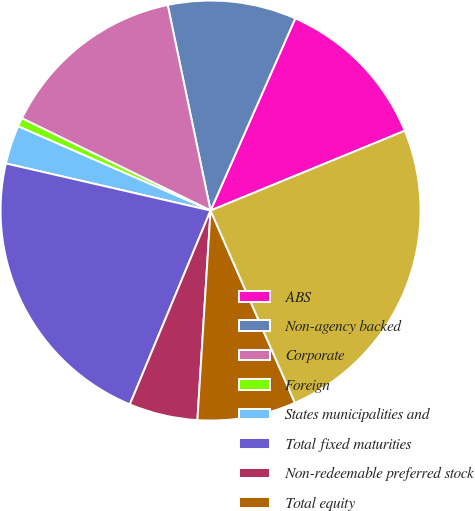Convert chart. <chart><loc_0><loc_0><loc_500><loc_500><pie_chart><fcel>ABS<fcel>Non-agency backed<fcel>Corporate<fcel>Foreign<fcel>States municipalities and<fcel>Total fixed maturities<fcel>Non-redeemable preferred stock<fcel>Total equity<fcel>Total temporarily impaired<nl><fcel>12.19%<fcel>9.88%<fcel>14.49%<fcel>0.67%<fcel>2.97%<fcel>22.32%<fcel>5.28%<fcel>7.58%<fcel>24.62%<nl></chart> 